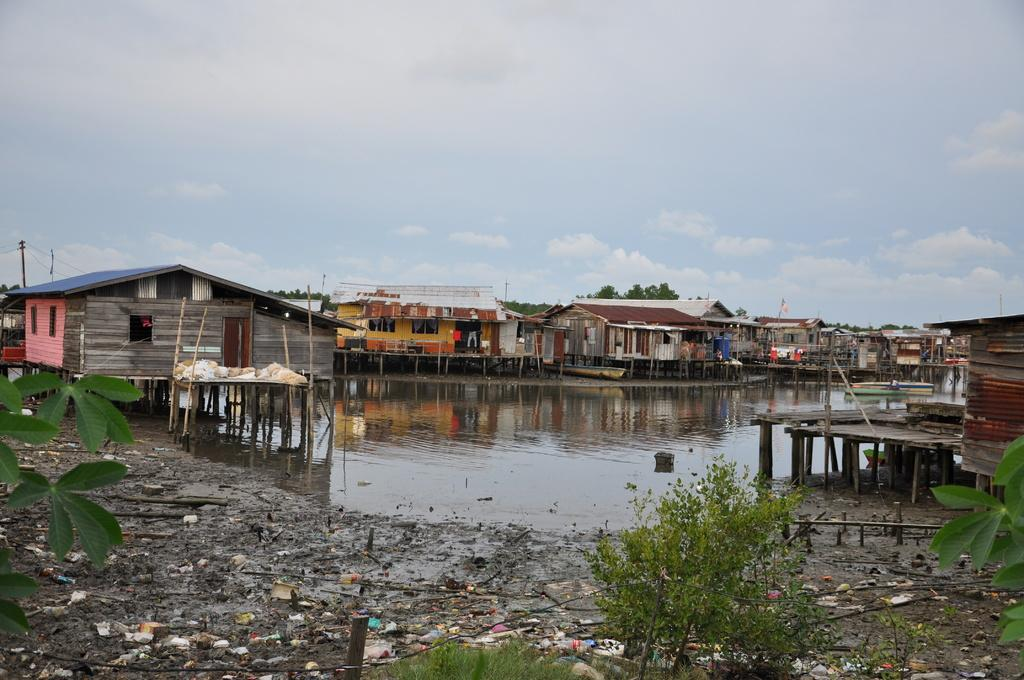What type of structures are located in the middle of the image? There are houses in the middle of the image. What natural feature is present in the middle of the image? There is water in the middle of the image. What type of vegetation is at the bottom of the image? There are bushes at the bottom of the image. What is visible at the top of the image? The sky is visible at the top of the image. Can you tell me how many dinosaurs are swimming in the water in the image? There are no dinosaurs present in the image; it features houses, water, bushes, and the sky. What arithmetic problem is being solved on the roof of one of the houses in the image? There is no arithmetic problem visible in the image; it only shows houses, water, bushes, and the sky. 